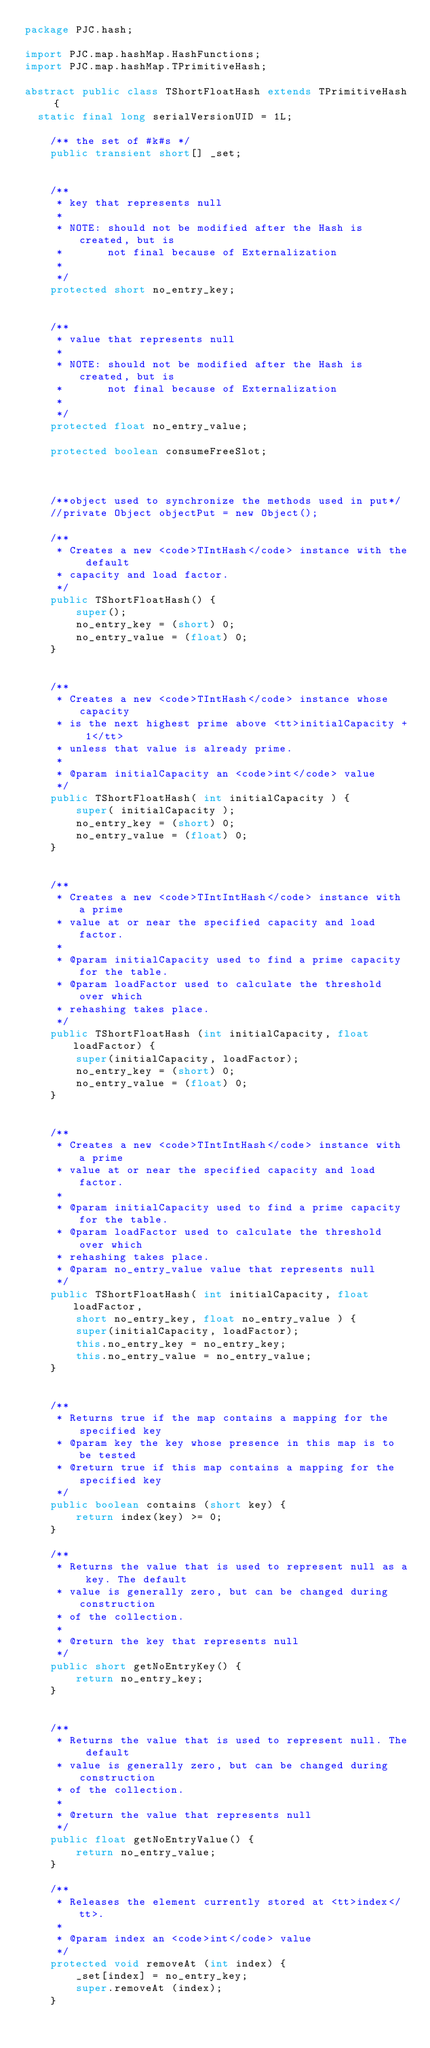Convert code to text. <code><loc_0><loc_0><loc_500><loc_500><_Java_>package PJC.hash;

import PJC.map.hashMap.HashFunctions;
import PJC.map.hashMap.TPrimitiveHash;

abstract public class TShortFloatHash extends TPrimitiveHash {
	static final long serialVersionUID = 1L;

    /** the set of #k#s */
    public transient short[] _set;


    /**
     * key that represents null
     *
     * NOTE: should not be modified after the Hash is created, but is
     *       not final because of Externalization
     *
     */
    protected short no_entry_key;


    /**
     * value that represents null
     *
     * NOTE: should not be modified after the Hash is created, but is
     *       not final because of Externalization
     *
     */
    protected float no_entry_value;

    protected boolean consumeFreeSlot;
   
    
    
    /**object used to synchronize the methods used in put*/
    //private Object objectPut = new Object();

    /**
     * Creates a new <code>TIntHash</code> instance with the default
     * capacity and load factor.
     */
    public TShortFloatHash() {
        super();
        no_entry_key = (short) 0;
        no_entry_value = (float) 0;
    }


    /**
     * Creates a new <code>TIntHash</code> instance whose capacity
     * is the next highest prime above <tt>initialCapacity + 1</tt>
     * unless that value is already prime.
     *
     * @param initialCapacity an <code>int</code> value
     */
    public TShortFloatHash( int initialCapacity ) {
        super( initialCapacity );
        no_entry_key = (short) 0;
        no_entry_value = (float) 0;
    }


    /**
     * Creates a new <code>TIntIntHash</code> instance with a prime
     * value at or near the specified capacity and load factor.
     *
     * @param initialCapacity used to find a prime capacity for the table.
     * @param loadFactor used to calculate the threshold over which
     * rehashing takes place.
     */
    public TShortFloatHash (int initialCapacity, float loadFactor) {
        super(initialCapacity, loadFactor);
        no_entry_key = (short) 0;
        no_entry_value = (float) 0;
    }


    /**
     * Creates a new <code>TIntIntHash</code> instance with a prime
     * value at or near the specified capacity and load factor.
     *
     * @param initialCapacity used to find a prime capacity for the table.
     * @param loadFactor used to calculate the threshold over which
     * rehashing takes place.
     * @param no_entry_value value that represents null
     */
    public TShortFloatHash( int initialCapacity, float loadFactor,
        short no_entry_key, float no_entry_value ) {
        super(initialCapacity, loadFactor);
        this.no_entry_key = no_entry_key;
        this.no_entry_value = no_entry_value;
    }
    

    /**
     * Returns true if the map contains a mapping for the specified key
     * @param key the key whose presence in this map is to be tested
     * @return true if this map contains a mapping for the specified key
     */
    public boolean contains (short key) {
        return index(key) >= 0;
    }

    /**
     * Returns the value that is used to represent null as a key. The default
     * value is generally zero, but can be changed during construction
     * of the collection.
     *
     * @return the key that represents null
     */
    public short getNoEntryKey() {
        return no_entry_key;
    }


    /**
     * Returns the value that is used to represent null. The default
     * value is generally zero, but can be changed during construction
     * of the collection.
     *
     * @return the value that represents null
     */
    public float getNoEntryValue() {
        return no_entry_value;
    }

    /**
     * Releases the element currently stored at <tt>index</tt>.
     *
     * @param index an <code>int</code> value
     */
    protected void removeAt (int index) {
        _set[index] = no_entry_key;
        super.removeAt (index);
    }
    </code> 